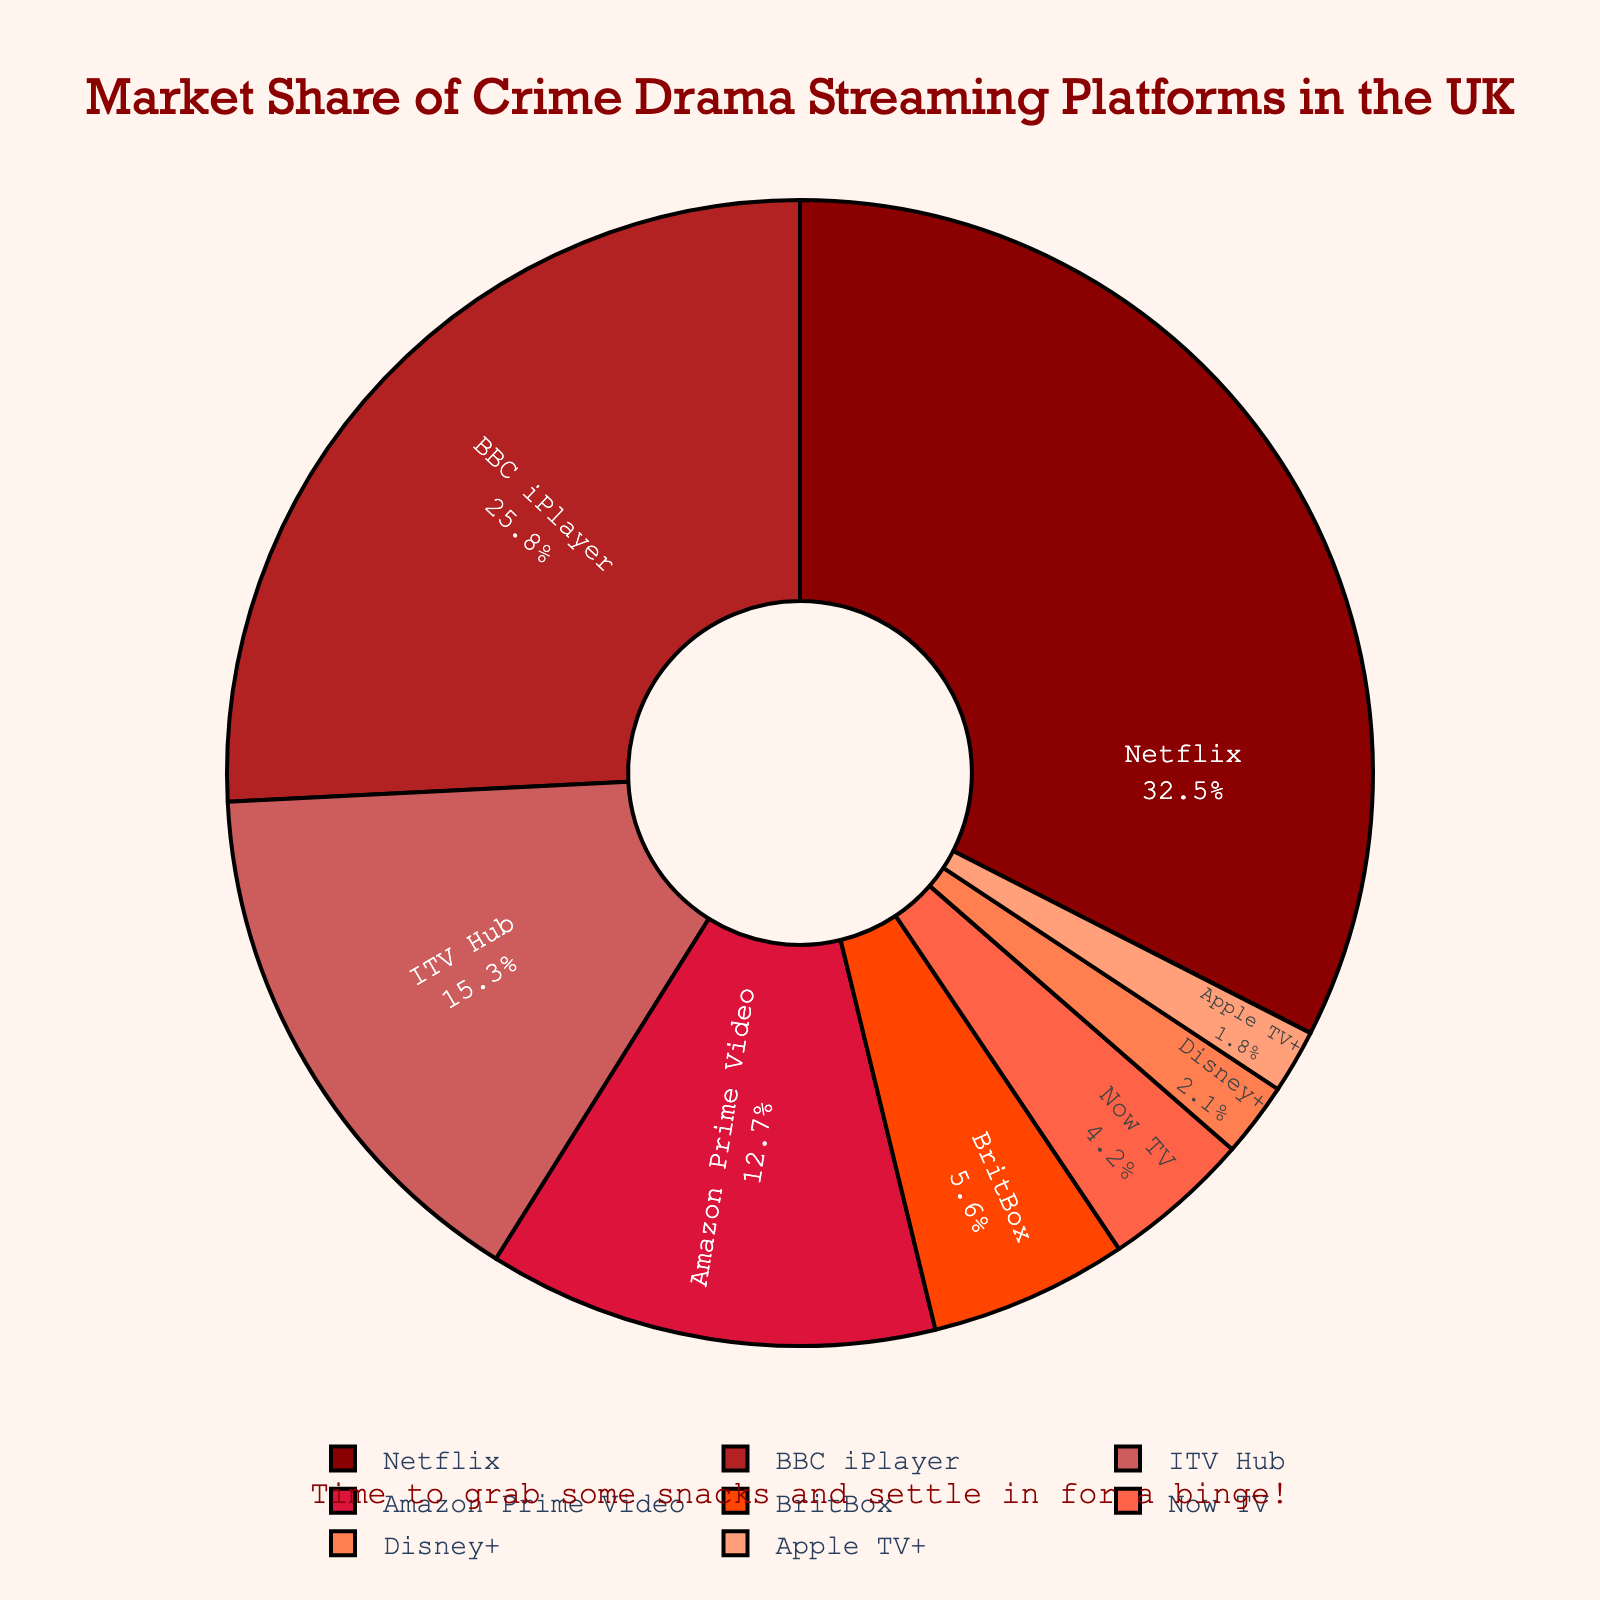What's the total market share of the top three platforms combined? To determine this, sum the market shares of Netflix (32.5%), BBC iPlayer (25.8%), and ITV Hub (15.3%). 32.5 + 25.8 + 15.3 = 73.6%
Answer: 73.6% How much larger is Netflix's market share compared to Apple TV+? Subtract the market share of Apple TV+ (1.8%) from Netflix (32.5%). 32.5 - 1.8 = 30.7%
Answer: 30.7% Which platforms have a market share greater than 10%? By inspecting the market shares, we see that Netflix (32.5%), BBC iPlayer (25.8%), ITV Hub (15.3%), and Amazon Prime Video (12.7%) all have market shares greater than 10%
Answer: Netflix, BBC iPlayer, ITV Hub, Amazon Prime Video What percentage of the market do the platforms with less than 5% share together hold? Add the market shares of BritBox (5.6%), Now TV (4.2%), Disney+ (2.1%), and Apple TV+ (1.8%). Since BritBox is slightly over 5%, we exclude it: 4.2 + 2.1 + 1.8 = 8.1%. Alternatively, including BritBox: 5.6 + 4.2 + 2.1 + 1.8 = 13.7%
Answer: 8.1% (exclude BritBox) or 13.7% (include BritBox) What's the difference between the market shares of ITV Hub and Amazon Prime Video? Subtract the market share of Amazon Prime Video (12.7%) from ITV Hub (15.3%). 15.3 - 12.7 = 2.6%
Answer: 2.6% Which streaming platform is represented in the darkest shade of red? The color representation shows that Netflix has the darkest shade of red.
Answer: Netflix If we combine BBC iPlayer, ITV Hub, and Amazon Prime Video, what is their combined market share, and how does it compare to Netflix's share? Sum the market shares of BBC iPlayer (25.8%), ITV Hub (15.3%), and Amazon Prime Video (12.7%) which gives 53.8%. Compare this to Netflix’s 32.5%. 53.8% - 32.5% = 21.3% more
Answer: 53.8% combined, 21.3% more than Netflix What is the second smallest market share, and which platform does it belong to? The smallest market share is Apple TV+ with 1.8%. The second smallest is Disney+ with 2.1%
Answer: Disney+, 2.1% Which platform's share is closest to 5%? BritBox has a market share of 5.6%, which is closest to 5% form the given data.
Answer: BritBox What's the sum of the market shares of platforms with names that start with a vowel? Platforms starting with a vowel are Apple TV+ (1.8%) and ITV Hub (15.3%). Sum: 1.8 + 15.3 = 17.1%
Answer: 17.1% 